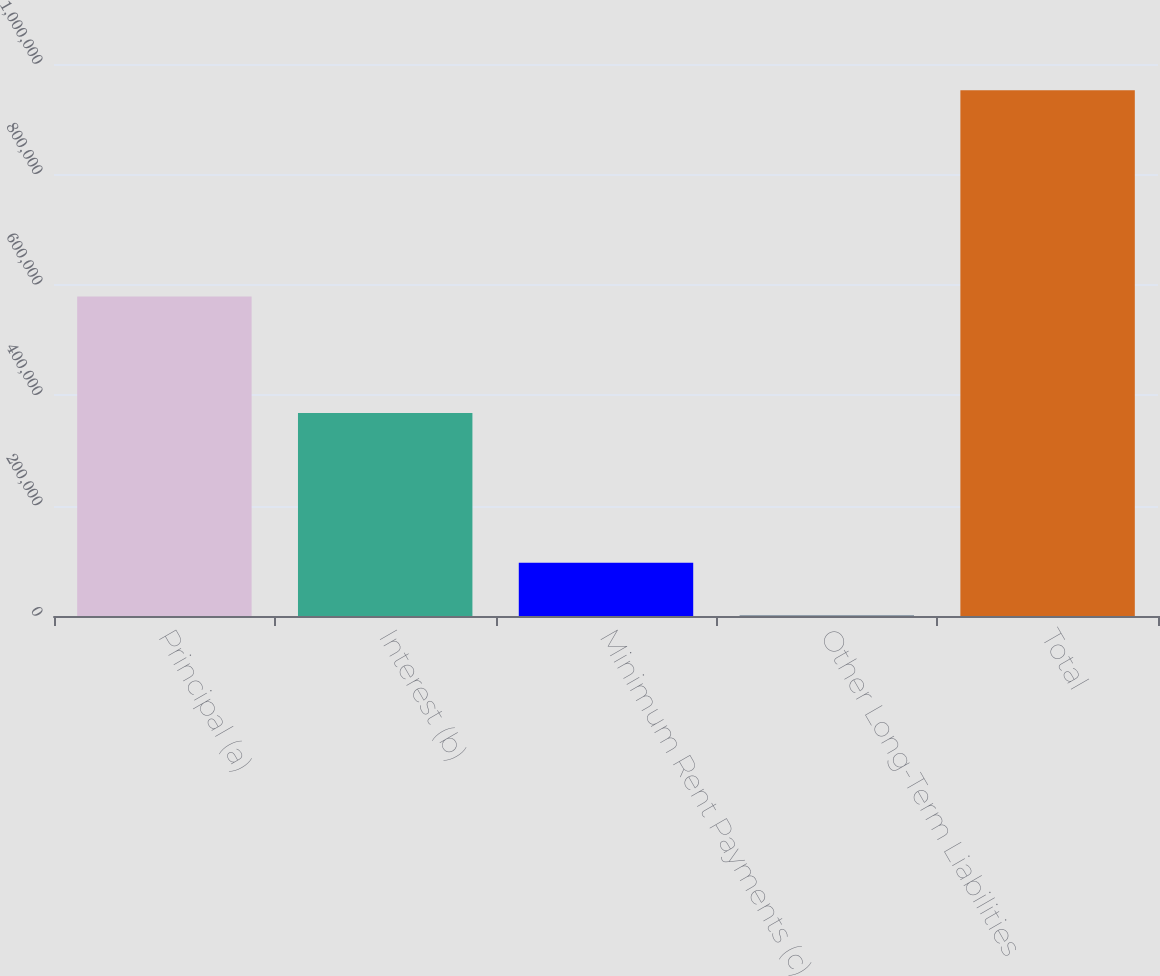Convert chart. <chart><loc_0><loc_0><loc_500><loc_500><bar_chart><fcel>Principal (a)<fcel>Interest (b)<fcel>Minimum Rent Payments (c)<fcel>Other Long-Term Liabilities<fcel>Total<nl><fcel>578987<fcel>367642<fcel>96591<fcel>1485<fcel>952545<nl></chart> 